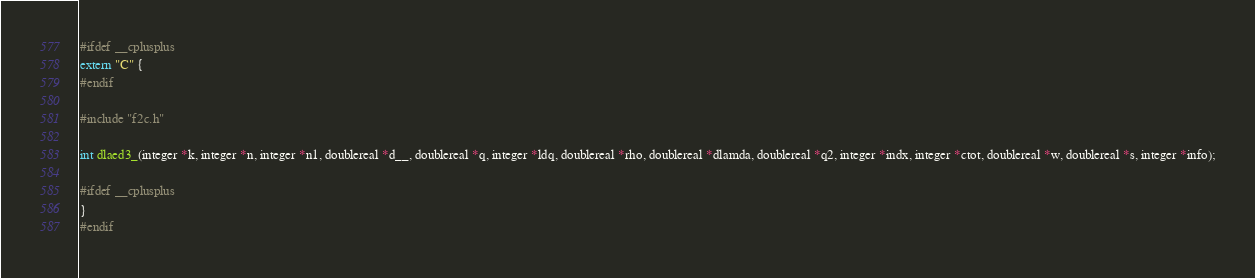Convert code to text. <code><loc_0><loc_0><loc_500><loc_500><_C_>#ifdef __cplusplus
extern "C" { 
#endif  

#include "f2c.h" 

int dlaed3_(integer *k, integer *n, integer *n1, doublereal *d__, doublereal *q, integer *ldq, doublereal *rho, doublereal *dlamda, doublereal *q2, integer *indx, integer *ctot, doublereal *w, doublereal *s, integer *info);

#ifdef __cplusplus
}
#endif</code> 